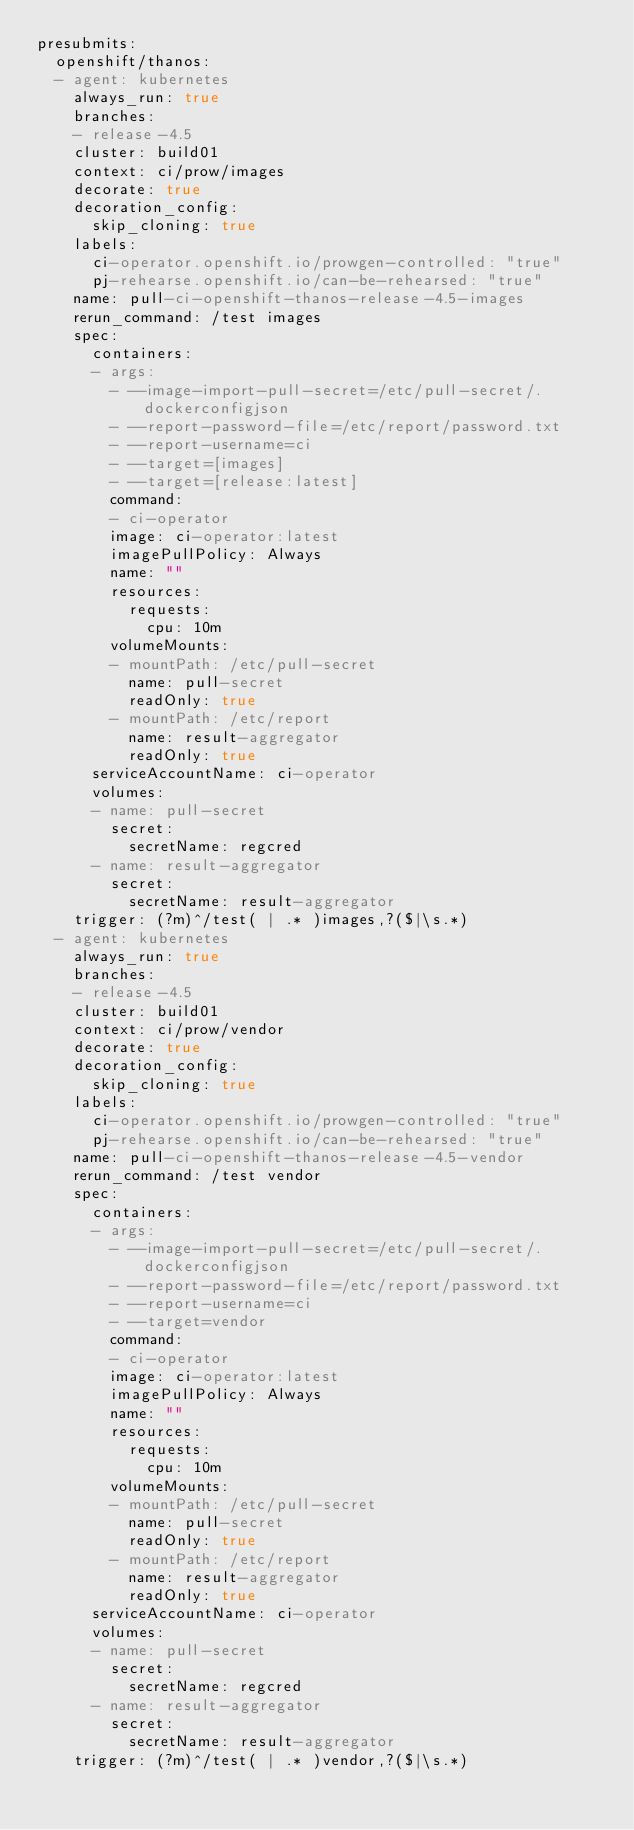Convert code to text. <code><loc_0><loc_0><loc_500><loc_500><_YAML_>presubmits:
  openshift/thanos:
  - agent: kubernetes
    always_run: true
    branches:
    - release-4.5
    cluster: build01
    context: ci/prow/images
    decorate: true
    decoration_config:
      skip_cloning: true
    labels:
      ci-operator.openshift.io/prowgen-controlled: "true"
      pj-rehearse.openshift.io/can-be-rehearsed: "true"
    name: pull-ci-openshift-thanos-release-4.5-images
    rerun_command: /test images
    spec:
      containers:
      - args:
        - --image-import-pull-secret=/etc/pull-secret/.dockerconfigjson
        - --report-password-file=/etc/report/password.txt
        - --report-username=ci
        - --target=[images]
        - --target=[release:latest]
        command:
        - ci-operator
        image: ci-operator:latest
        imagePullPolicy: Always
        name: ""
        resources:
          requests:
            cpu: 10m
        volumeMounts:
        - mountPath: /etc/pull-secret
          name: pull-secret
          readOnly: true
        - mountPath: /etc/report
          name: result-aggregator
          readOnly: true
      serviceAccountName: ci-operator
      volumes:
      - name: pull-secret
        secret:
          secretName: regcred
      - name: result-aggregator
        secret:
          secretName: result-aggregator
    trigger: (?m)^/test( | .* )images,?($|\s.*)
  - agent: kubernetes
    always_run: true
    branches:
    - release-4.5
    cluster: build01
    context: ci/prow/vendor
    decorate: true
    decoration_config:
      skip_cloning: true
    labels:
      ci-operator.openshift.io/prowgen-controlled: "true"
      pj-rehearse.openshift.io/can-be-rehearsed: "true"
    name: pull-ci-openshift-thanos-release-4.5-vendor
    rerun_command: /test vendor
    spec:
      containers:
      - args:
        - --image-import-pull-secret=/etc/pull-secret/.dockerconfigjson
        - --report-password-file=/etc/report/password.txt
        - --report-username=ci
        - --target=vendor
        command:
        - ci-operator
        image: ci-operator:latest
        imagePullPolicy: Always
        name: ""
        resources:
          requests:
            cpu: 10m
        volumeMounts:
        - mountPath: /etc/pull-secret
          name: pull-secret
          readOnly: true
        - mountPath: /etc/report
          name: result-aggregator
          readOnly: true
      serviceAccountName: ci-operator
      volumes:
      - name: pull-secret
        secret:
          secretName: regcred
      - name: result-aggregator
        secret:
          secretName: result-aggregator
    trigger: (?m)^/test( | .* )vendor,?($|\s.*)
</code> 